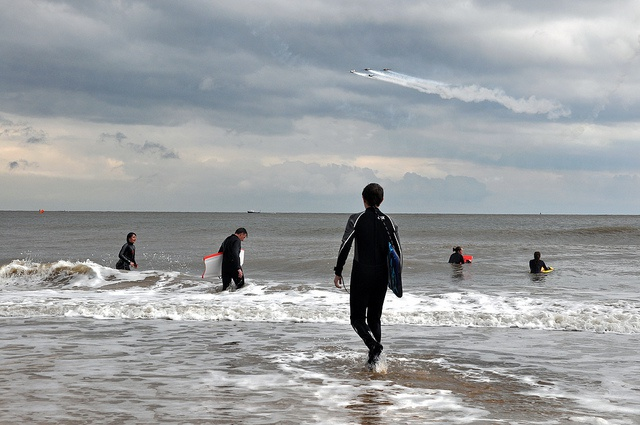Describe the objects in this image and their specific colors. I can see people in darkgray, black, gray, and lightgray tones, people in darkgray, black, gray, and maroon tones, people in darkgray, black, gray, and maroon tones, surfboard in darkgray, black, navy, gray, and blue tones, and surfboard in darkgray, gray, red, and lightgray tones in this image. 